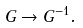<formula> <loc_0><loc_0><loc_500><loc_500>G \rightarrow G ^ { - 1 } .</formula> 